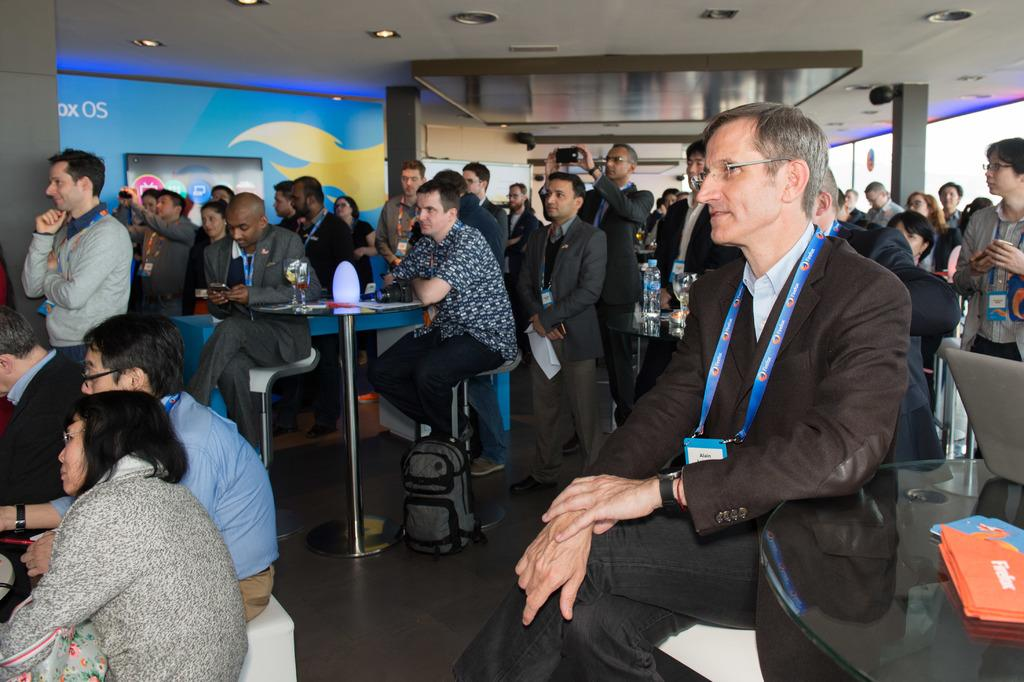What is: How many people are in the image? There is a group of people in the image. Can you describe any specific features of the people in the image? Some people in the group are wearing ID cards. What can be seen in the background of the image? There is a roof visible in the background of the image. What type of brass instrument is being played by the fireman in the image? There is no fireman or brass instrument present in the image. 